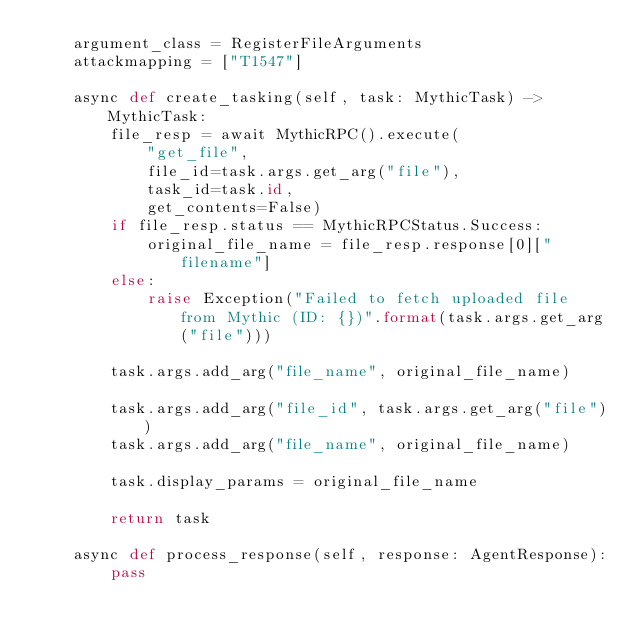<code> <loc_0><loc_0><loc_500><loc_500><_Python_>    argument_class = RegisterFileArguments
    attackmapping = ["T1547"]

    async def create_tasking(self, task: MythicTask) -> MythicTask:
        file_resp = await MythicRPC().execute(
            "get_file",
            file_id=task.args.get_arg("file"),
            task_id=task.id,
            get_contents=False)
        if file_resp.status == MythicRPCStatus.Success:
            original_file_name = file_resp.response[0]["filename"]
        else:
            raise Exception("Failed to fetch uploaded file from Mythic (ID: {})".format(task.args.get_arg("file")))
        
        task.args.add_arg("file_name", original_file_name)

        task.args.add_arg("file_id", task.args.get_arg("file"))
        task.args.add_arg("file_name", original_file_name)
        
        task.display_params = original_file_name
        
        return task

    async def process_response(self, response: AgentResponse):
        pass
</code> 